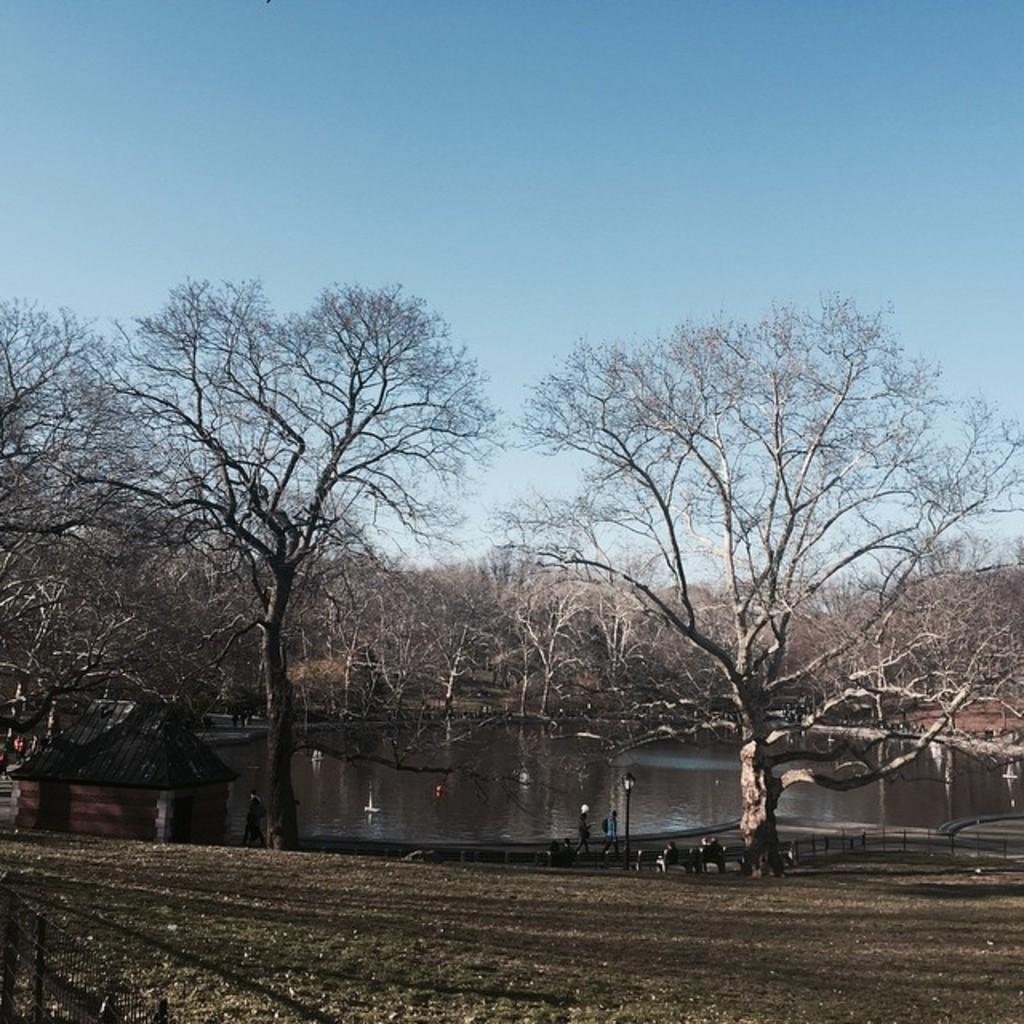Who or what is located in the middle of the image? There are people in the middle of the image. What type of body of water is present in the image? It appears to be a pond in the image. What type of vegetation can be seen in the image? There are trees in the image. What is visible at the top of the image? The sky is visible at the top of the image. What type of car is parked near the pond in the image? There is no car present in the image; it features people, a pond, trees, and the sky. What type of swing can be seen in the image? There is no swing present in the image. 